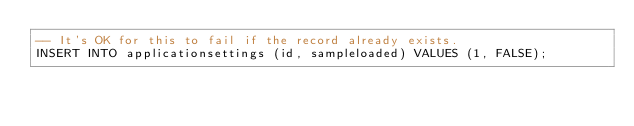<code> <loc_0><loc_0><loc_500><loc_500><_SQL_>-- It's OK for this to fail if the record already exists.
INSERT INTO applicationsettings (id, sampleloaded) VALUES (1, FALSE);
</code> 